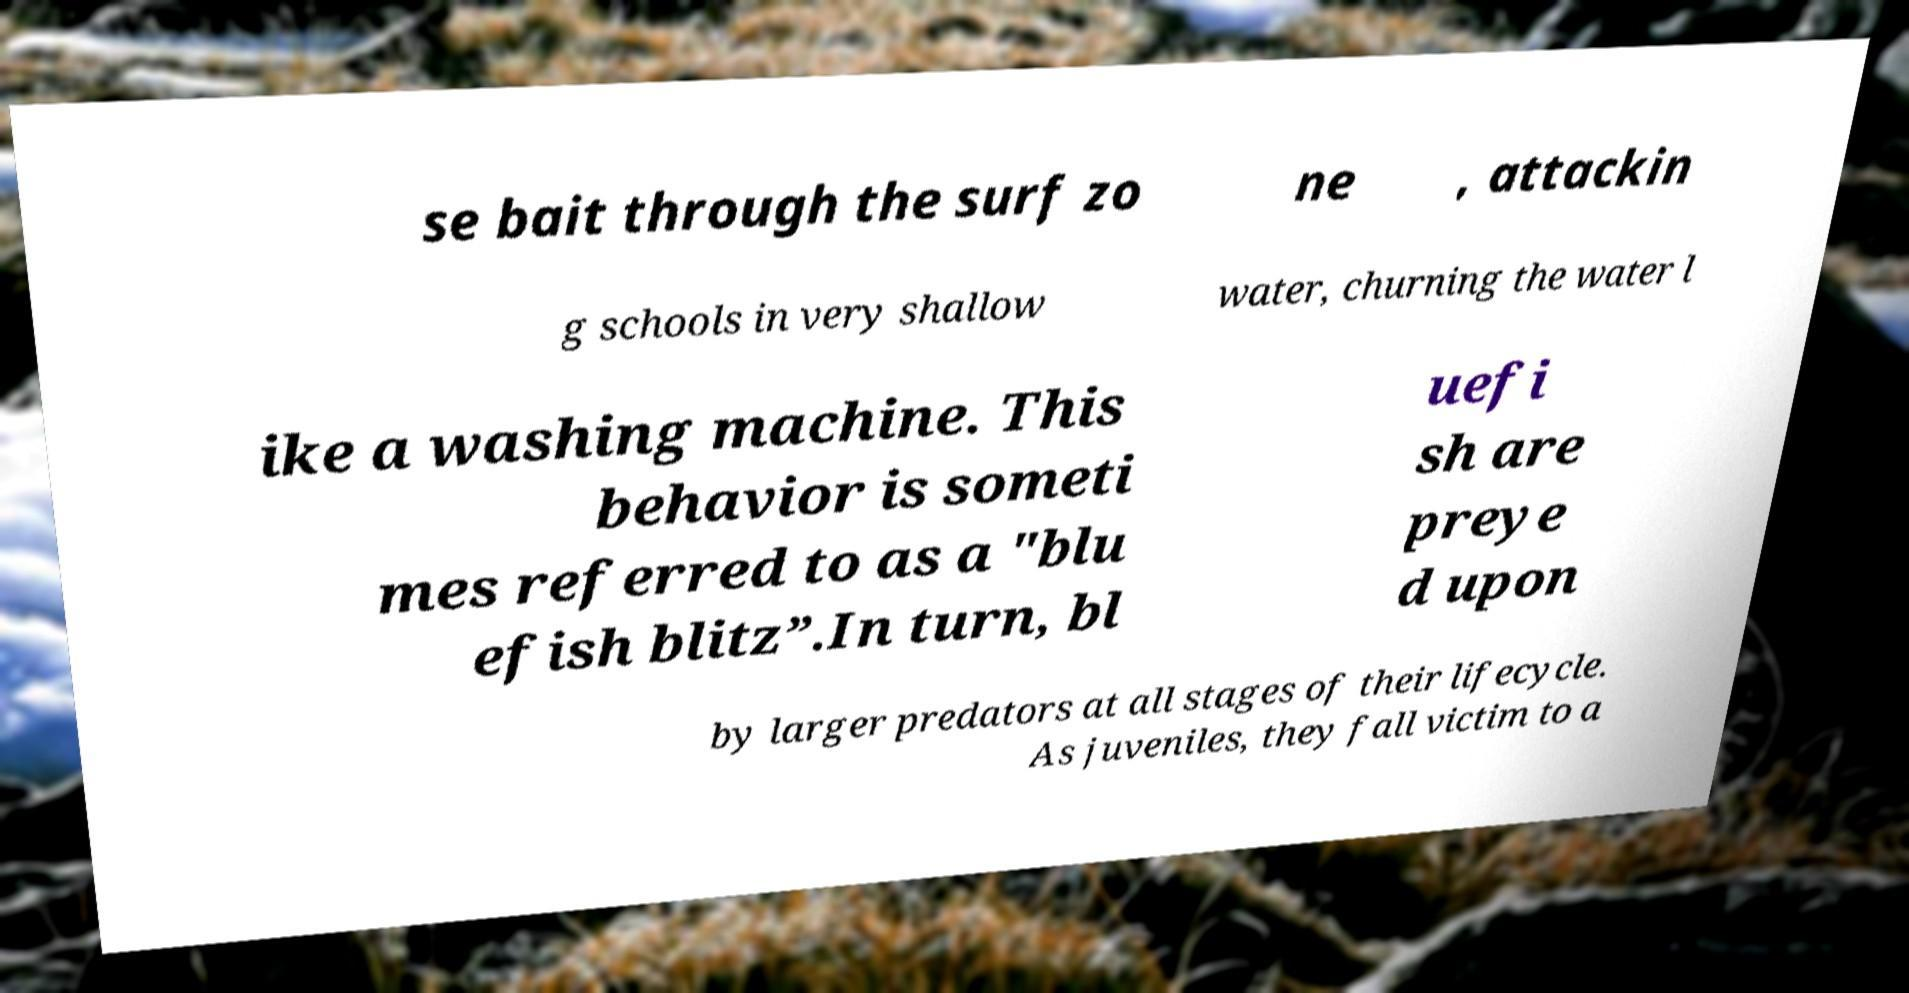Could you extract and type out the text from this image? se bait through the surf zo ne , attackin g schools in very shallow water, churning the water l ike a washing machine. This behavior is someti mes referred to as a "blu efish blitz”.In turn, bl uefi sh are preye d upon by larger predators at all stages of their lifecycle. As juveniles, they fall victim to a 